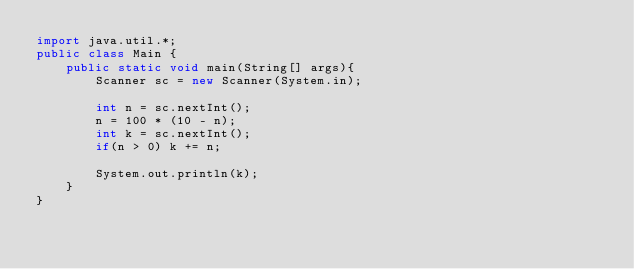<code> <loc_0><loc_0><loc_500><loc_500><_Java_>import java.util.*;
public class Main {
	public static void main(String[] args){
		Scanner sc = new Scanner(System.in);
		
        int n = sc.nextInt();
      	n = 100 * (10 - n);
      	int k = sc.nextInt();
      	if(n > 0) k += n;
      
      	System.out.println(k);      	        
	}
}</code> 